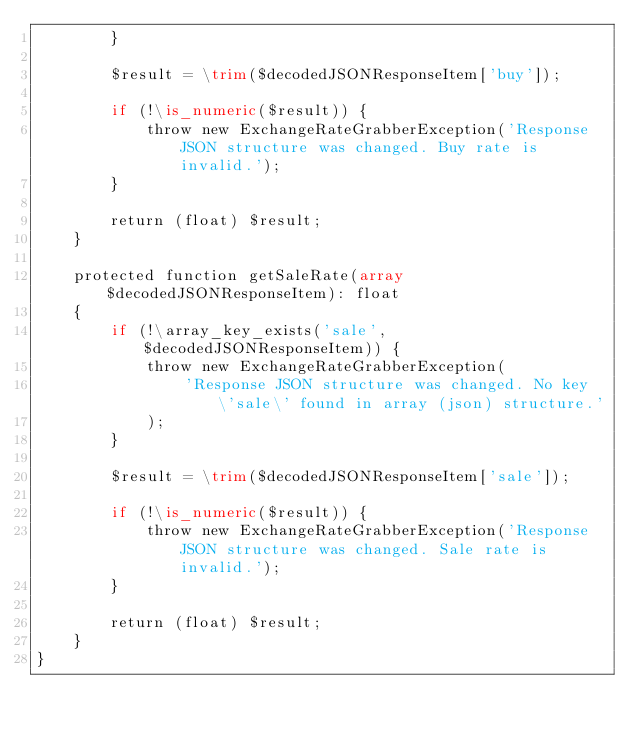Convert code to text. <code><loc_0><loc_0><loc_500><loc_500><_PHP_>        }

        $result = \trim($decodedJSONResponseItem['buy']);

        if (!\is_numeric($result)) {
            throw new ExchangeRateGrabberException('Response JSON structure was changed. Buy rate is invalid.');
        }

        return (float) $result;
    }

    protected function getSaleRate(array $decodedJSONResponseItem): float
    {
        if (!\array_key_exists('sale', $decodedJSONResponseItem)) {
            throw new ExchangeRateGrabberException(
                'Response JSON structure was changed. No key \'sale\' found in array (json) structure.'
            );
        }

        $result = \trim($decodedJSONResponseItem['sale']);

        if (!\is_numeric($result)) {
            throw new ExchangeRateGrabberException('Response JSON structure was changed. Sale rate is invalid.');
        }

        return (float) $result;
    }
}
</code> 